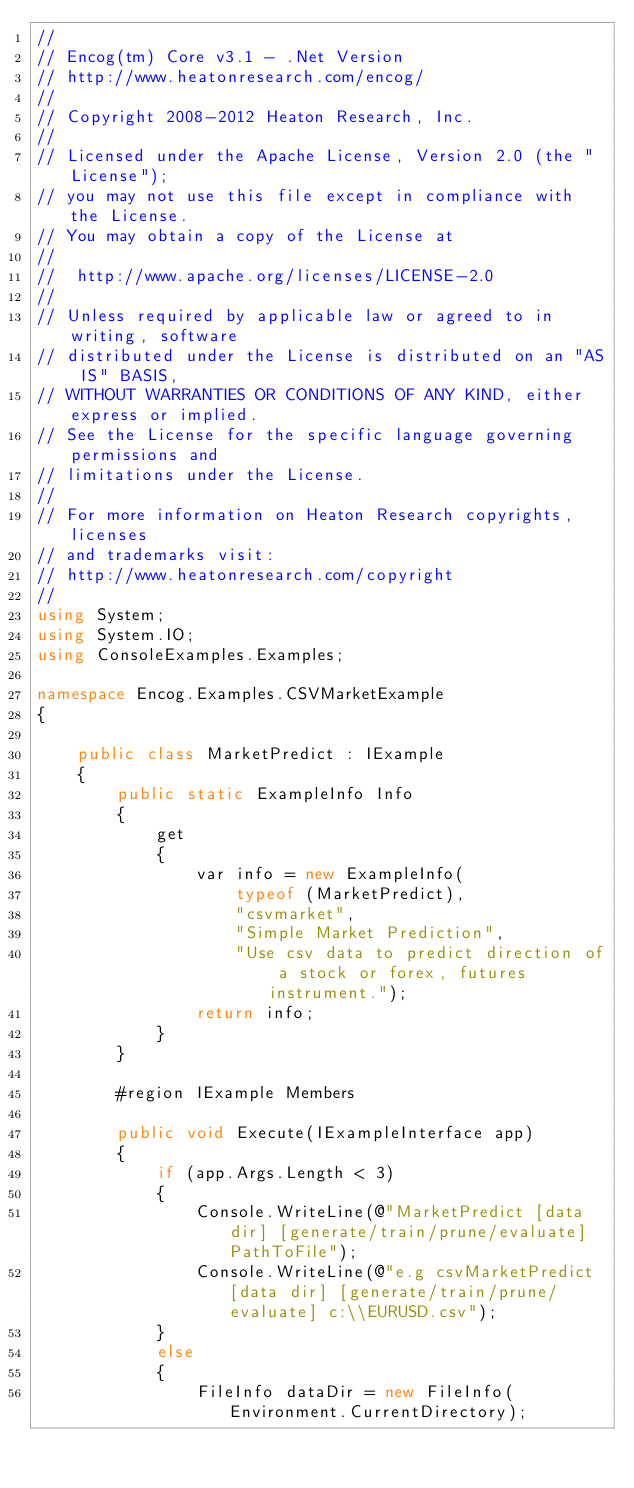<code> <loc_0><loc_0><loc_500><loc_500><_C#_>//
// Encog(tm) Core v3.1 - .Net Version
// http://www.heatonresearch.com/encog/
//
// Copyright 2008-2012 Heaton Research, Inc.
//
// Licensed under the Apache License, Version 2.0 (the "License");
// you may not use this file except in compliance with the License.
// You may obtain a copy of the License at
//
//  http://www.apache.org/licenses/LICENSE-2.0
//
// Unless required by applicable law or agreed to in writing, software
// distributed under the License is distributed on an "AS IS" BASIS,
// WITHOUT WARRANTIES OR CONDITIONS OF ANY KIND, either express or implied.
// See the License for the specific language governing permissions and
// limitations under the License.
//   
// For more information on Heaton Research copyrights, licenses 
// and trademarks visit:
// http://www.heatonresearch.com/copyright
//
using System;
using System.IO;
using ConsoleExamples.Examples;

namespace Encog.Examples.CSVMarketExample
{

    public class MarketPredict : IExample
    {
        public static ExampleInfo Info
        {
            get
            {
                var info = new ExampleInfo(
                    typeof (MarketPredict),
                    "csvmarket",
                    "Simple Market Prediction",
                    "Use csv data to predict direction of a stock or forex, futures instrument.");
                return info;
            }
        }

        #region IExample Members

        public void Execute(IExampleInterface app)
        {
            if (app.Args.Length < 3)
            {
                Console.WriteLine(@"MarketPredict [data dir] [generate/train/prune/evaluate] PathToFile");
                Console.WriteLine(@"e.g csvMarketPredict [data dir] [generate/train/prune/evaluate] c:\\EURUSD.csv");
            }
            else
            {
                FileInfo dataDir = new FileInfo(Environment.CurrentDirectory);</code> 